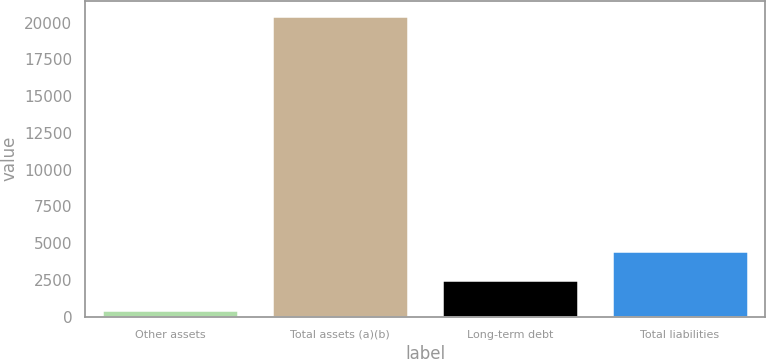Convert chart. <chart><loc_0><loc_0><loc_500><loc_500><bar_chart><fcel>Other assets<fcel>Total assets (a)(b)<fcel>Long-term debt<fcel>Total liabilities<nl><fcel>481<fcel>20466<fcel>2479.5<fcel>4478<nl></chart> 